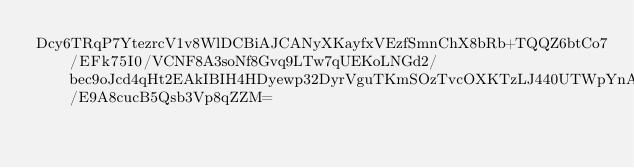Convert code to text. <code><loc_0><loc_0><loc_500><loc_500><_SML_>Dcy6TRqP7YtezrcV1v8WlDCBiAJCANyXKayfxVEzfSmnChX8bRb+TQQZ6btCo7/EFk75I0/VCNF8A3soNf8Gvq9LTw7qUEKoLNGd2/bec9oJcd4qHt2EAkIBIH4HDyewp32DyrVguTKmSOzTvcOXKTzLJ440UTWpYnADI656BvJT28Rmuhw9c5j0Uw/E9A8cucB5Qsb3Vp8qZZM=</code> 